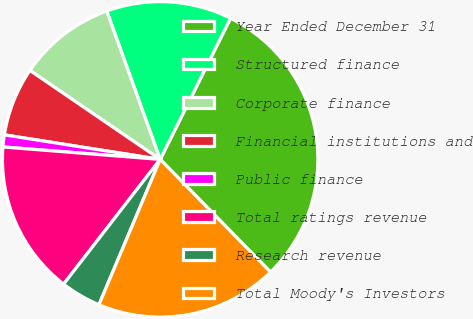<chart> <loc_0><loc_0><loc_500><loc_500><pie_chart><fcel>Year Ended December 31<fcel>Structured finance<fcel>Corporate finance<fcel>Financial institutions and<fcel>Public finance<fcel>Total ratings revenue<fcel>Research revenue<fcel>Total Moody's Investors<nl><fcel>30.31%<fcel>12.86%<fcel>9.96%<fcel>7.05%<fcel>1.23%<fcel>15.77%<fcel>4.14%<fcel>18.68%<nl></chart> 